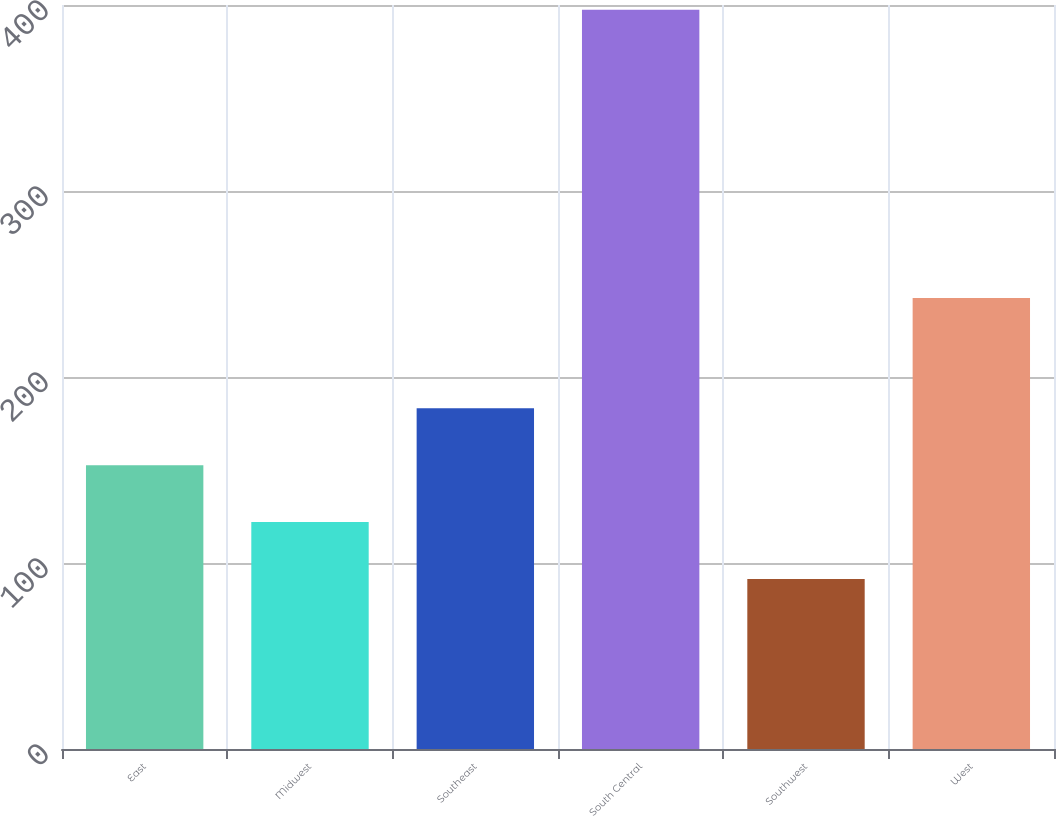Convert chart. <chart><loc_0><loc_0><loc_500><loc_500><bar_chart><fcel>East<fcel>Midwest<fcel>Southeast<fcel>South Central<fcel>Southwest<fcel>West<nl><fcel>152.62<fcel>122.01<fcel>183.23<fcel>397.5<fcel>91.4<fcel>242.5<nl></chart> 